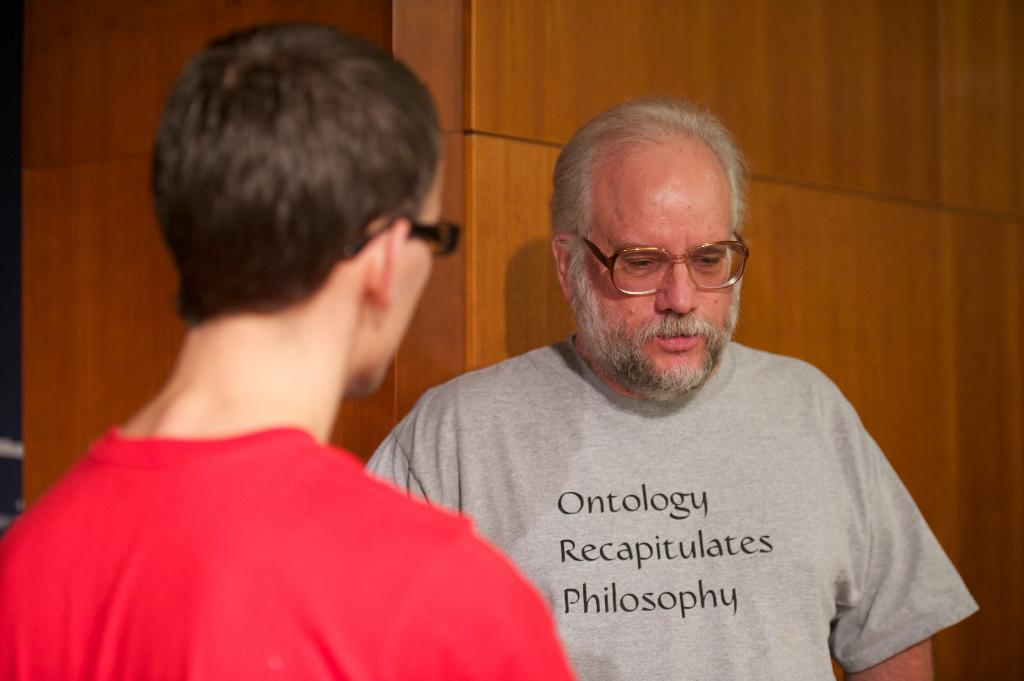How many people are in the image? There are two men in the image. What can be observed about the men's appearance? Both men are wearing spectacles. Can you describe the clothing of the men? The man on the left is wearing a red t-shirt, and the man on the right is wearing a grey t-shirt. What is the background made of in the image? The background in the image is made of wood. What type of farm animals can be seen in the image? There are no farm animals present in the image. What is the men's reaction to the cream in the image? There is no cream present in the image, and therefore no reaction can be observed. 